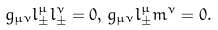Convert formula to latex. <formula><loc_0><loc_0><loc_500><loc_500>g _ { \mu \nu } l _ { \pm } ^ { \mu } l _ { \pm } ^ { \nu } = 0 , \, g _ { \mu \nu } l _ { \pm } ^ { \mu } m ^ { \nu } = 0 .</formula> 